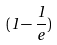Convert formula to latex. <formula><loc_0><loc_0><loc_500><loc_500>( 1 - \frac { 1 } { e } )</formula> 